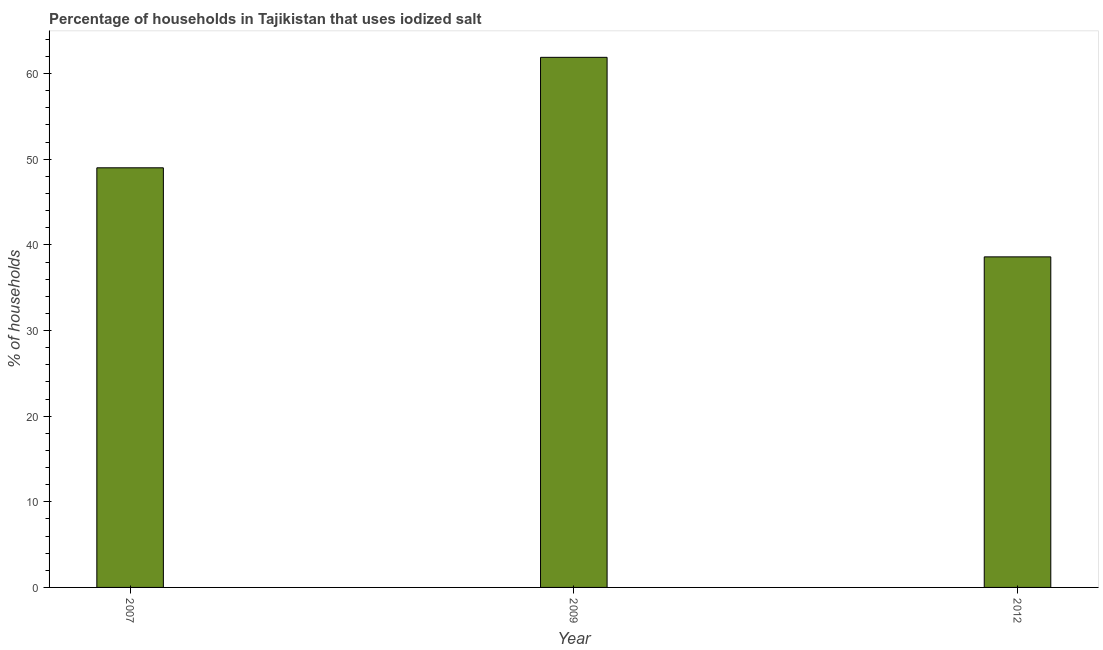Does the graph contain any zero values?
Your answer should be compact. No. Does the graph contain grids?
Provide a succinct answer. No. What is the title of the graph?
Your answer should be compact. Percentage of households in Tajikistan that uses iodized salt. What is the label or title of the X-axis?
Provide a short and direct response. Year. What is the label or title of the Y-axis?
Provide a succinct answer. % of households. Across all years, what is the maximum percentage of households where iodized salt is consumed?
Keep it short and to the point. 61.9. Across all years, what is the minimum percentage of households where iodized salt is consumed?
Your response must be concise. 38.6. In which year was the percentage of households where iodized salt is consumed minimum?
Keep it short and to the point. 2012. What is the sum of the percentage of households where iodized salt is consumed?
Provide a succinct answer. 149.5. What is the average percentage of households where iodized salt is consumed per year?
Ensure brevity in your answer.  49.83. In how many years, is the percentage of households where iodized salt is consumed greater than 62 %?
Ensure brevity in your answer.  0. What is the ratio of the percentage of households where iodized salt is consumed in 2009 to that in 2012?
Provide a succinct answer. 1.6. Is the percentage of households where iodized salt is consumed in 2007 less than that in 2012?
Offer a very short reply. No. Is the difference between the percentage of households where iodized salt is consumed in 2007 and 2009 greater than the difference between any two years?
Give a very brief answer. No. What is the difference between the highest and the second highest percentage of households where iodized salt is consumed?
Your answer should be very brief. 12.9. What is the difference between the highest and the lowest percentage of households where iodized salt is consumed?
Offer a terse response. 23.3. How many bars are there?
Your response must be concise. 3. Are all the bars in the graph horizontal?
Your response must be concise. No. How many years are there in the graph?
Offer a terse response. 3. Are the values on the major ticks of Y-axis written in scientific E-notation?
Give a very brief answer. No. What is the % of households of 2009?
Provide a succinct answer. 61.9. What is the % of households of 2012?
Keep it short and to the point. 38.6. What is the difference between the % of households in 2009 and 2012?
Ensure brevity in your answer.  23.3. What is the ratio of the % of households in 2007 to that in 2009?
Your answer should be very brief. 0.79. What is the ratio of the % of households in 2007 to that in 2012?
Offer a very short reply. 1.27. What is the ratio of the % of households in 2009 to that in 2012?
Ensure brevity in your answer.  1.6. 